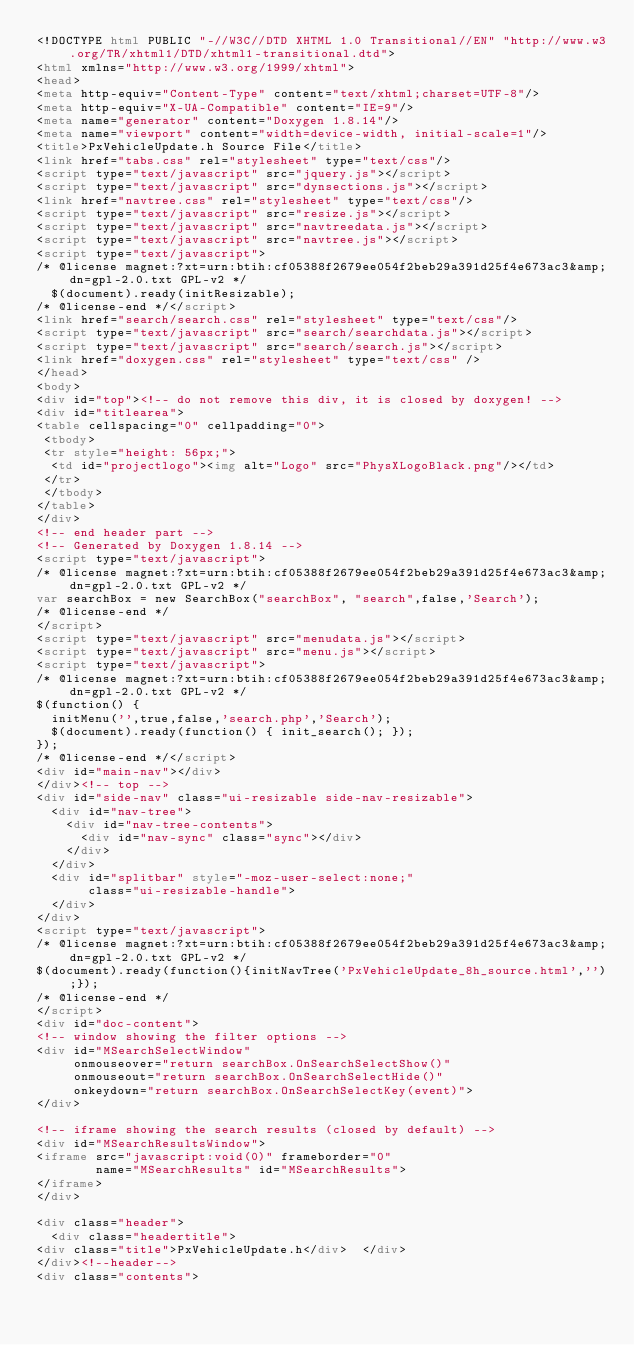Convert code to text. <code><loc_0><loc_0><loc_500><loc_500><_HTML_><!DOCTYPE html PUBLIC "-//W3C//DTD XHTML 1.0 Transitional//EN" "http://www.w3.org/TR/xhtml1/DTD/xhtml1-transitional.dtd">
<html xmlns="http://www.w3.org/1999/xhtml">
<head>
<meta http-equiv="Content-Type" content="text/xhtml;charset=UTF-8"/>
<meta http-equiv="X-UA-Compatible" content="IE=9"/>
<meta name="generator" content="Doxygen 1.8.14"/>
<meta name="viewport" content="width=device-width, initial-scale=1"/>
<title>PxVehicleUpdate.h Source File</title>
<link href="tabs.css" rel="stylesheet" type="text/css"/>
<script type="text/javascript" src="jquery.js"></script>
<script type="text/javascript" src="dynsections.js"></script>
<link href="navtree.css" rel="stylesheet" type="text/css"/>
<script type="text/javascript" src="resize.js"></script>
<script type="text/javascript" src="navtreedata.js"></script>
<script type="text/javascript" src="navtree.js"></script>
<script type="text/javascript">
/* @license magnet:?xt=urn:btih:cf05388f2679ee054f2beb29a391d25f4e673ac3&amp;dn=gpl-2.0.txt GPL-v2 */
  $(document).ready(initResizable);
/* @license-end */</script>
<link href="search/search.css" rel="stylesheet" type="text/css"/>
<script type="text/javascript" src="search/searchdata.js"></script>
<script type="text/javascript" src="search/search.js"></script>
<link href="doxygen.css" rel="stylesheet" type="text/css" />
</head>
<body>
<div id="top"><!-- do not remove this div, it is closed by doxygen! -->
<div id="titlearea">
<table cellspacing="0" cellpadding="0">
 <tbody>
 <tr style="height: 56px;">
  <td id="projectlogo"><img alt="Logo" src="PhysXLogoBlack.png"/></td>
 </tr>
 </tbody>
</table>
</div>
<!-- end header part -->
<!-- Generated by Doxygen 1.8.14 -->
<script type="text/javascript">
/* @license magnet:?xt=urn:btih:cf05388f2679ee054f2beb29a391d25f4e673ac3&amp;dn=gpl-2.0.txt GPL-v2 */
var searchBox = new SearchBox("searchBox", "search",false,'Search');
/* @license-end */
</script>
<script type="text/javascript" src="menudata.js"></script>
<script type="text/javascript" src="menu.js"></script>
<script type="text/javascript">
/* @license magnet:?xt=urn:btih:cf05388f2679ee054f2beb29a391d25f4e673ac3&amp;dn=gpl-2.0.txt GPL-v2 */
$(function() {
  initMenu('',true,false,'search.php','Search');
  $(document).ready(function() { init_search(); });
});
/* @license-end */</script>
<div id="main-nav"></div>
</div><!-- top -->
<div id="side-nav" class="ui-resizable side-nav-resizable">
  <div id="nav-tree">
    <div id="nav-tree-contents">
      <div id="nav-sync" class="sync"></div>
    </div>
  </div>
  <div id="splitbar" style="-moz-user-select:none;" 
       class="ui-resizable-handle">
  </div>
</div>
<script type="text/javascript">
/* @license magnet:?xt=urn:btih:cf05388f2679ee054f2beb29a391d25f4e673ac3&amp;dn=gpl-2.0.txt GPL-v2 */
$(document).ready(function(){initNavTree('PxVehicleUpdate_8h_source.html','');});
/* @license-end */
</script>
<div id="doc-content">
<!-- window showing the filter options -->
<div id="MSearchSelectWindow"
     onmouseover="return searchBox.OnSearchSelectShow()"
     onmouseout="return searchBox.OnSearchSelectHide()"
     onkeydown="return searchBox.OnSearchSelectKey(event)">
</div>

<!-- iframe showing the search results (closed by default) -->
<div id="MSearchResultsWindow">
<iframe src="javascript:void(0)" frameborder="0" 
        name="MSearchResults" id="MSearchResults">
</iframe>
</div>

<div class="header">
  <div class="headertitle">
<div class="title">PxVehicleUpdate.h</div>  </div>
</div><!--header-->
<div class="contents"></code> 